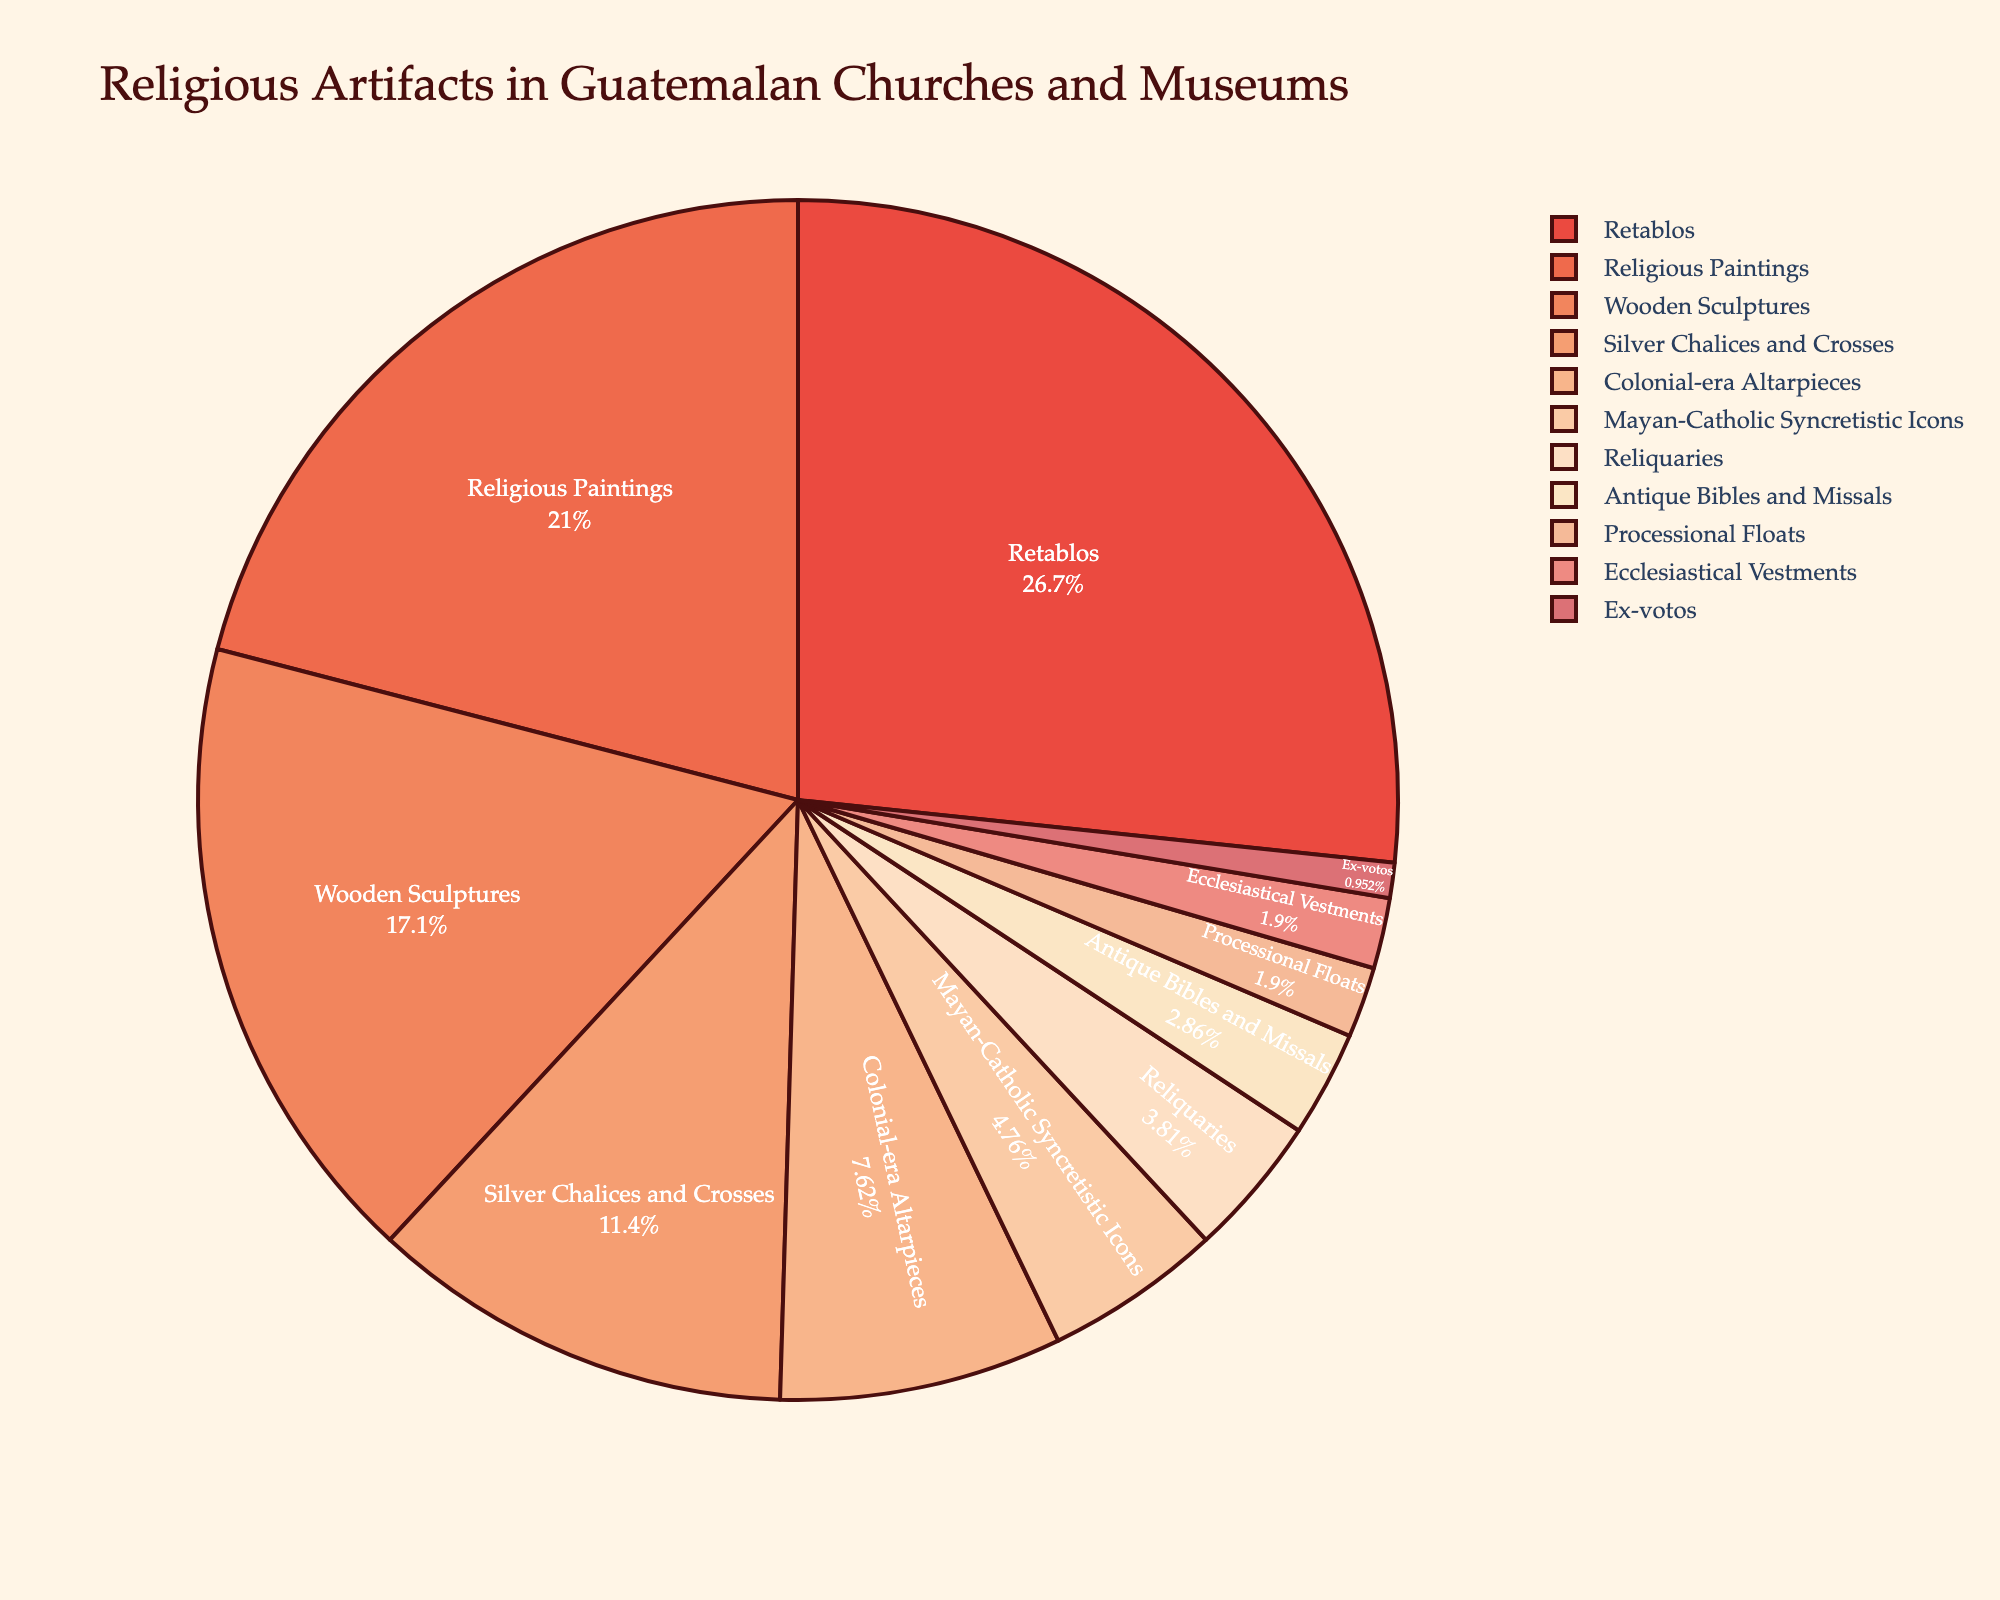What's the largest category of religious artifacts in Guatemalan churches and museums? By examining the pie chart, it's clear that the largest category is visually the biggest section of the pie. This section represents 'Retablos'.
Answer: Retablos How much greater is the percentage of Retablos compared to Mayan-Catholic Syncretistic Icons? First, identify the percentages from the pie chart: Retablos are 28%, and Mayan-Catholic Syncretistic Icons are 5%. The difference is calculated by subtracting 5% from 28%.
Answer: 23% Which category has the smallest percentage? The smallest sector of the pie chart is the narrowest slice. This slice represents 'Ex-votos'.
Answer: Ex-votos What is the combined percentage of Wooden Sculptures and Silver Chalices and Crosses? First, find the percentages for both categories: Wooden Sculptures are 18%, and Silver Chalices and Crosses are 12%. Adding these together, 18% + 12%, gives the combined percentage.
Answer: 30% Does the percentage of Religious Paintings exceed the combined percentage of Ecclesiastical Vestments and Processional Floats? Find the percentage for Religious Paintings (22%) and compare it to the combined percentage of Ecclesiastical Vestments (2%) and Processional Floats (2%), which sum up to 4%. Thus, 22% is greater than 4%.
Answer: Yes Which three categories have the largest representation, and what is their total percentage? First, identify the three categories with the largest percentages: Retablos (28%), Religious Paintings (22%), and Wooden Sculptures (18%). Adding these together gives 28% + 22% + 18%, totaling the combined percentage.
Answer: Retablos, Religious Paintings, Wooden Sculptures; 68% Is the percentage of Colonial-era Altarpieces less than Reliquaries? Identify the percentages: Colonial-era Altarpieces are 8%, and Reliquaries are 4%. Compare 8% to 4%; 8% is greater than 4%. So, no, it is not less.
Answer: No If the percentage of Silver Chalices and Crosses doubled, would it be greater than Retablos? The current percentage for Silver Chalices and Crosses is 12%. If it doubled, it would be 12% x 2 = 24%. This is still less than the percentage for Retablos, which is 28%.
Answer: No What's the difference in percentage between Antique Bibles and Missals, and Ex-votos? Identify the percentages for each: Antique Bibles and Missals are 3%, and Ex-votos are 1%. The difference is calculated by subtracting 1% from 3%, which is 3% - 1% = 2%.
Answer: 2% Which category is represented in colors closer to the red spectrum in the pie chart? By examining the color palette used in the pie chart, which is a combination of sequential Peach and Burgyl colors, you would typically see warm colors like peach and red towards these artifacts. Checking visually should indicate a category such as 'Retablos', which uses a warmer tone.
Answer: Retablos 